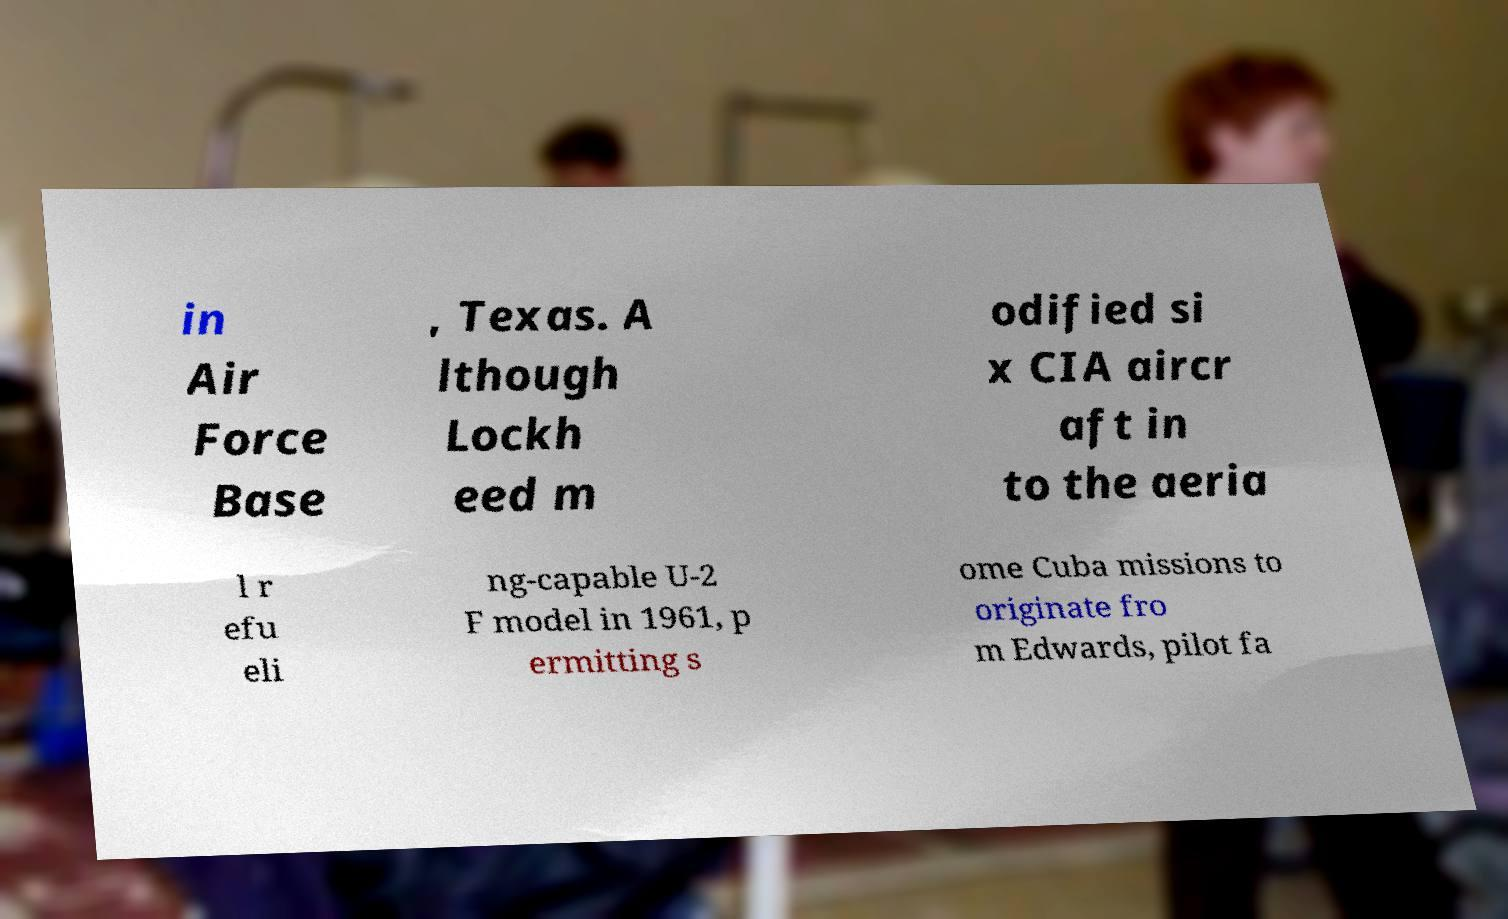I need the written content from this picture converted into text. Can you do that? in Air Force Base , Texas. A lthough Lockh eed m odified si x CIA aircr aft in to the aeria l r efu eli ng-capable U-2 F model in 1961, p ermitting s ome Cuba missions to originate fro m Edwards, pilot fa 